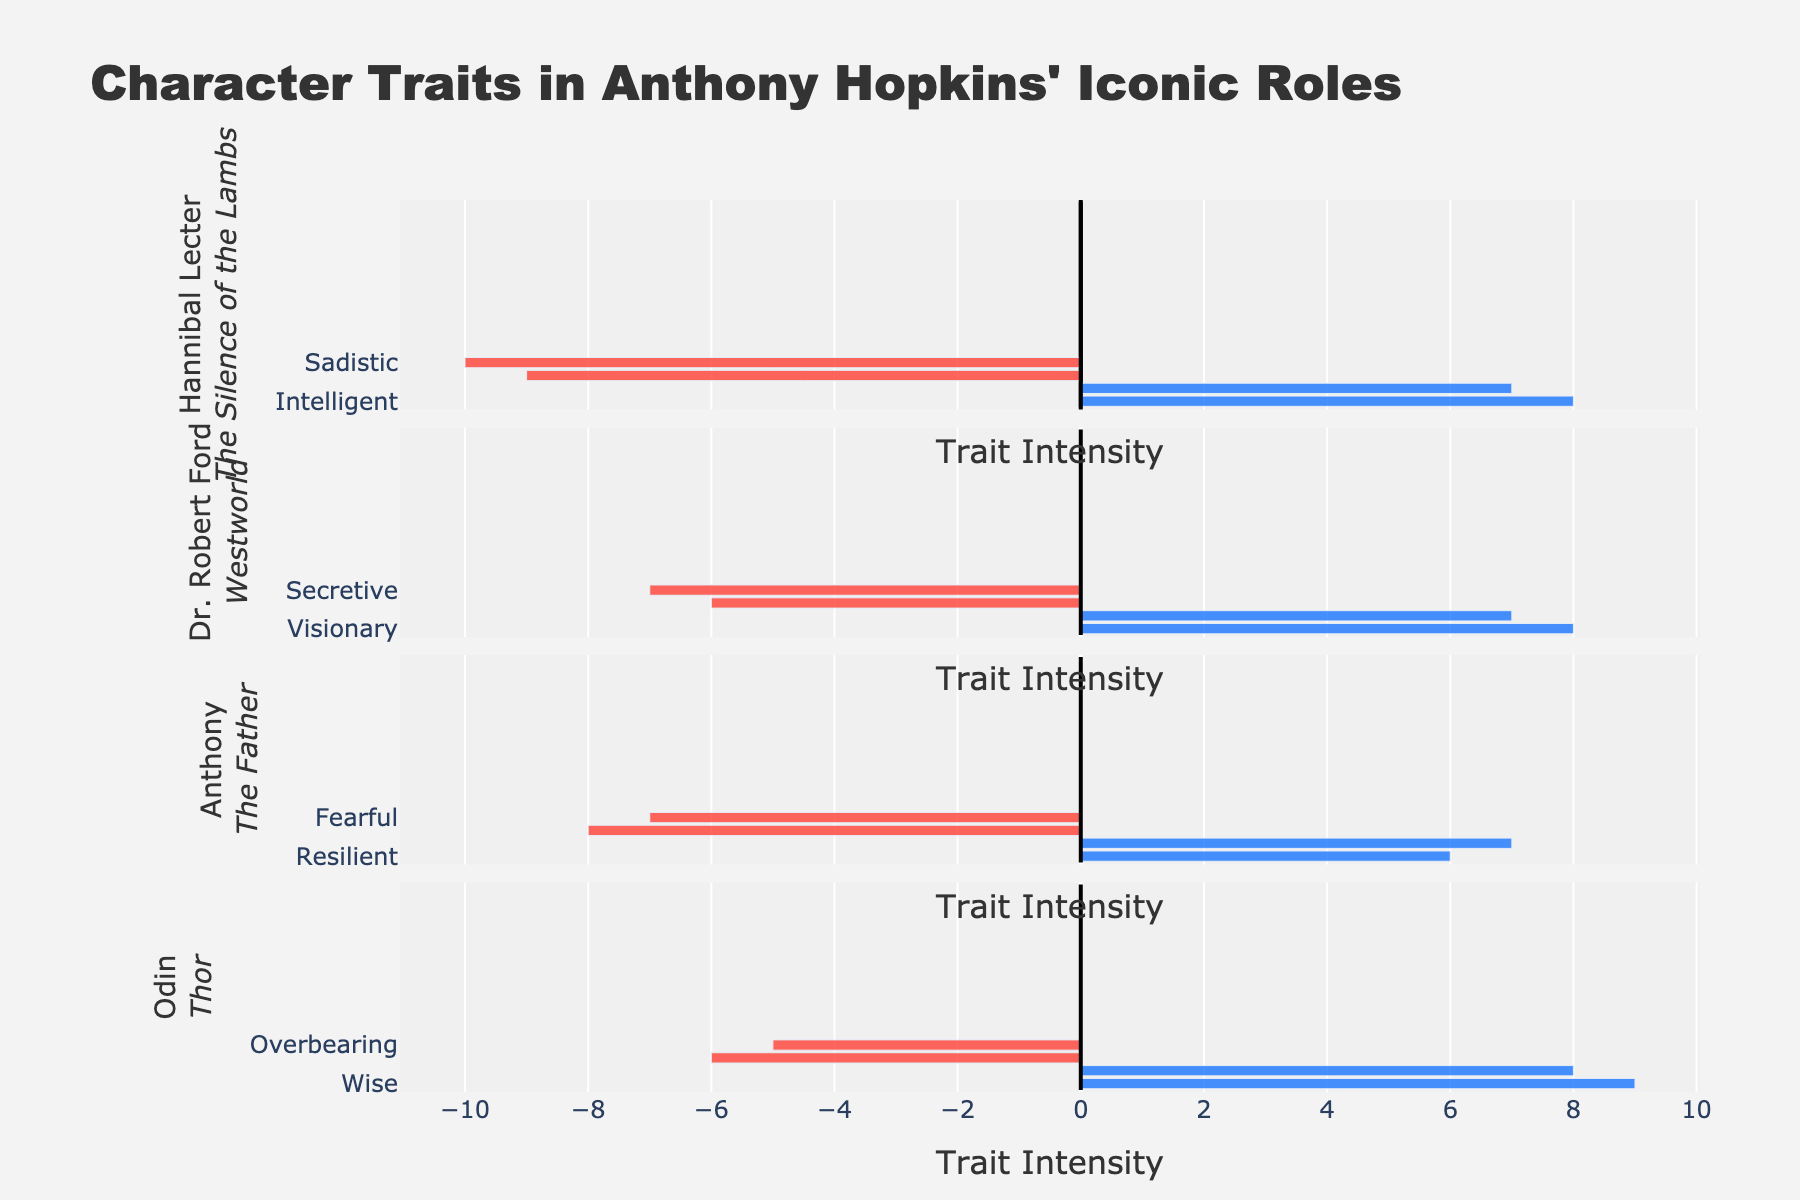What are the most intense positive and negative traits of Hannibal Lecter in "The Silence of the Lambs"? For Hannibal Lecter, each positive and negative trait's intensity can be read off the lengths of the respective bars. The most intense positive trait is "Intelligent" with an intensity of 8, and the most intense negative trait is "Sadistic" with an intensity of 10.
Answer: Intelligent: 8; Sadistic: 10 Which character has the highest positive trait intensity and what is that trait? By comparing the lengths of all the positive traits' bars, we see that Odin from "Thor" has the highest positive trait intensity with "Wise" at 9.
Answer: Odin, Wise: 9 Who has a higher overall positive trait intensity in "The Father," Anthony or Dr. Robert Ford in "Westworld"? Sum the positive trait intensities for each character. For Anthony: 6 (Resilient) + 7 (Loving) = 13. For Dr. Robert Ford: 8 (Visionary) + 7 (Philosophical) = 15. By comparing these sums, Dr. Robert Ford has a higher overall positive trait intensity.
Answer: Dr. Robert Ford: 15 Which character's traits show the greatest balance between positive and negative intensities based on the figure? This can be determined by observing the lengths of both positive and negative trait bars for each character and looking for relatively equal lengths. Anthony in "The Father" shows a close balance. Positive traits: 6 (Resilient) and 7 (Loving). Negative traits: 8 (Confused) and 7 (Fearful).
Answer: Anthony Overall, which role portrays a more negative impression, Dr. Robert Ford in "Westworld" or Hannibal Lecter in "The Silence of the Lambs"? Compare the negative trait intensities for Dr. Robert Ford and Hannibal Lecter. Dr. Robert Ford's negative traits are "Ruthless: 6" and "Secretive: 7" totaling -13. Hannibal Lecter's negative traits are "Manipulative: 9" and "Sadistic: 10", totaling -19. Hannibal Lecter's role portrays a more negative impression.
Answer: Hannibal Lecter Which character exhibits the least negative trait intensity and what is the trait? Compare the lengths of all the negative traits' bars to identify the shortest bar. Odin in "Thor" has the least negative trait intensity with "Overbearing" at 5.
Answer: Odin, Overbearing: 5 